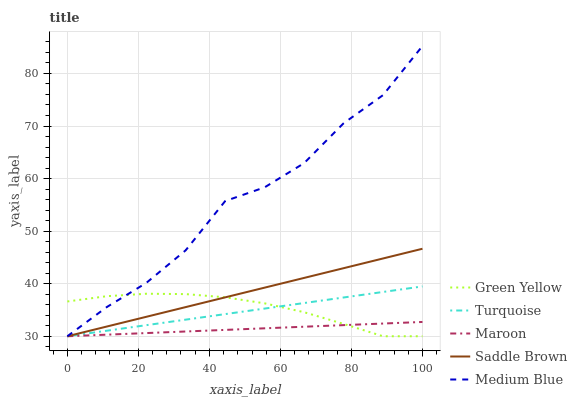Does Maroon have the minimum area under the curve?
Answer yes or no. Yes. Does Medium Blue have the maximum area under the curve?
Answer yes or no. Yes. Does Green Yellow have the minimum area under the curve?
Answer yes or no. No. Does Green Yellow have the maximum area under the curve?
Answer yes or no. No. Is Saddle Brown the smoothest?
Answer yes or no. Yes. Is Medium Blue the roughest?
Answer yes or no. Yes. Is Green Yellow the smoothest?
Answer yes or no. No. Is Green Yellow the roughest?
Answer yes or no. No. Does Turquoise have the lowest value?
Answer yes or no. Yes. Does Medium Blue have the highest value?
Answer yes or no. Yes. Does Green Yellow have the highest value?
Answer yes or no. No. Does Maroon intersect Medium Blue?
Answer yes or no. Yes. Is Maroon less than Medium Blue?
Answer yes or no. No. Is Maroon greater than Medium Blue?
Answer yes or no. No. 